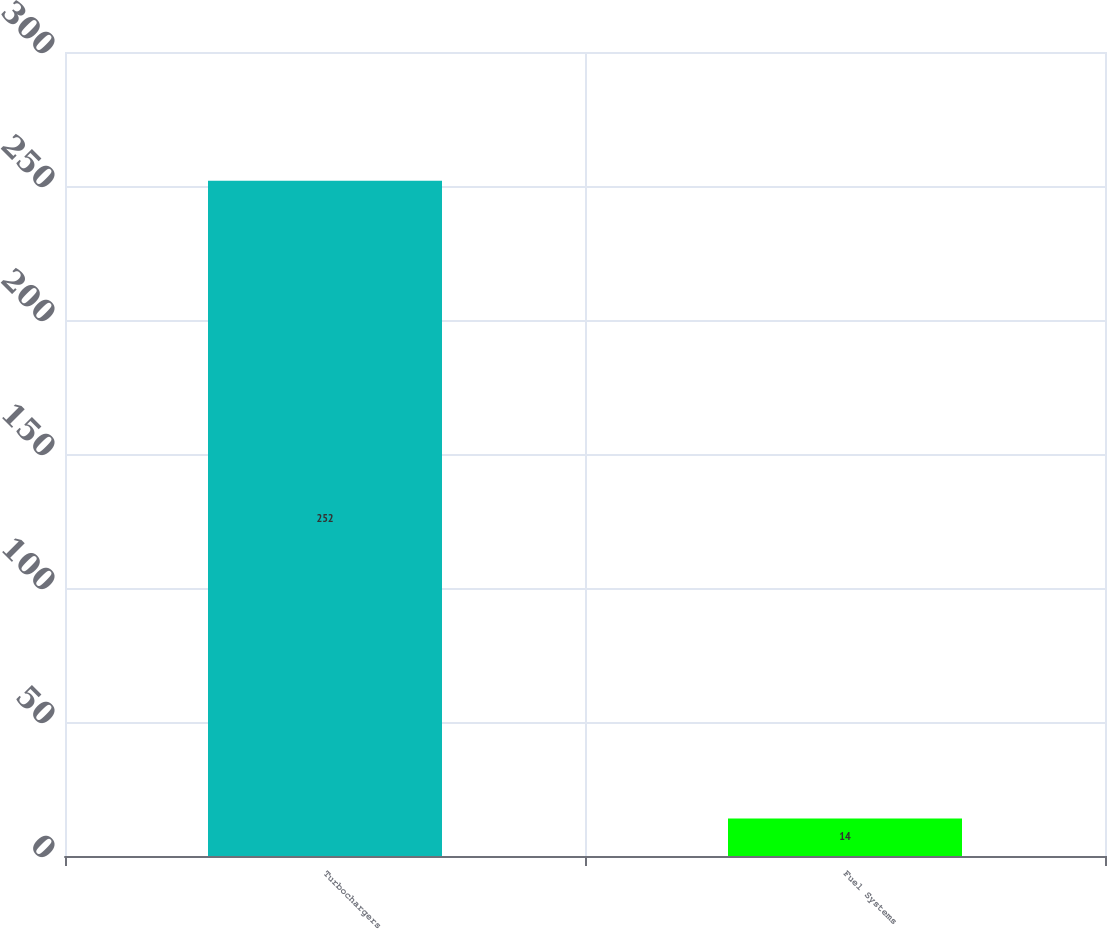Convert chart. <chart><loc_0><loc_0><loc_500><loc_500><bar_chart><fcel>Turbochargers<fcel>Fuel Systems<nl><fcel>252<fcel>14<nl></chart> 